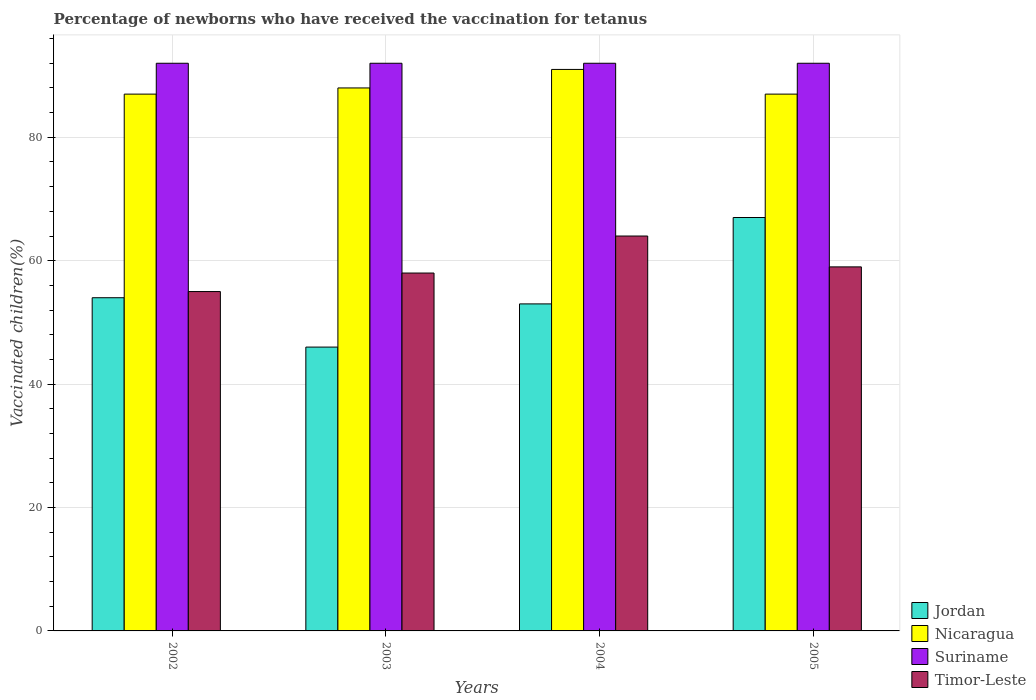How many groups of bars are there?
Ensure brevity in your answer.  4. Are the number of bars on each tick of the X-axis equal?
Ensure brevity in your answer.  Yes. How many bars are there on the 1st tick from the right?
Give a very brief answer. 4. What is the label of the 2nd group of bars from the left?
Give a very brief answer. 2003. Across all years, what is the maximum percentage of vaccinated children in Suriname?
Your answer should be very brief. 92. What is the total percentage of vaccinated children in Timor-Leste in the graph?
Your answer should be compact. 236. What is the difference between the percentage of vaccinated children in Suriname in 2003 and that in 2004?
Your response must be concise. 0. What is the difference between the percentage of vaccinated children in Jordan in 2003 and the percentage of vaccinated children in Timor-Leste in 2002?
Your answer should be compact. -9. What is the average percentage of vaccinated children in Timor-Leste per year?
Your answer should be compact. 59. What is the ratio of the percentage of vaccinated children in Nicaragua in 2002 to that in 2005?
Your answer should be very brief. 1. What is the difference between the highest and the second highest percentage of vaccinated children in Jordan?
Your answer should be very brief. 13. In how many years, is the percentage of vaccinated children in Suriname greater than the average percentage of vaccinated children in Suriname taken over all years?
Your answer should be compact. 0. Is the sum of the percentage of vaccinated children in Suriname in 2004 and 2005 greater than the maximum percentage of vaccinated children in Nicaragua across all years?
Offer a very short reply. Yes. What does the 3rd bar from the left in 2002 represents?
Offer a very short reply. Suriname. What does the 2nd bar from the right in 2005 represents?
Your answer should be very brief. Suriname. Are all the bars in the graph horizontal?
Ensure brevity in your answer.  No. How many years are there in the graph?
Provide a short and direct response. 4. What is the difference between two consecutive major ticks on the Y-axis?
Provide a short and direct response. 20. Are the values on the major ticks of Y-axis written in scientific E-notation?
Offer a very short reply. No. Does the graph contain any zero values?
Give a very brief answer. No. Does the graph contain grids?
Your response must be concise. Yes. Where does the legend appear in the graph?
Keep it short and to the point. Bottom right. How many legend labels are there?
Give a very brief answer. 4. How are the legend labels stacked?
Provide a short and direct response. Vertical. What is the title of the graph?
Offer a terse response. Percentage of newborns who have received the vaccination for tetanus. What is the label or title of the Y-axis?
Make the answer very short. Vaccinated children(%). What is the Vaccinated children(%) in Jordan in 2002?
Provide a short and direct response. 54. What is the Vaccinated children(%) in Nicaragua in 2002?
Offer a terse response. 87. What is the Vaccinated children(%) in Suriname in 2002?
Ensure brevity in your answer.  92. What is the Vaccinated children(%) of Timor-Leste in 2002?
Give a very brief answer. 55. What is the Vaccinated children(%) of Jordan in 2003?
Your answer should be very brief. 46. What is the Vaccinated children(%) of Suriname in 2003?
Offer a very short reply. 92. What is the Vaccinated children(%) of Timor-Leste in 2003?
Your response must be concise. 58. What is the Vaccinated children(%) of Jordan in 2004?
Your answer should be very brief. 53. What is the Vaccinated children(%) in Nicaragua in 2004?
Offer a very short reply. 91. What is the Vaccinated children(%) of Suriname in 2004?
Offer a very short reply. 92. What is the Vaccinated children(%) of Timor-Leste in 2004?
Ensure brevity in your answer.  64. What is the Vaccinated children(%) of Jordan in 2005?
Provide a short and direct response. 67. What is the Vaccinated children(%) in Suriname in 2005?
Offer a very short reply. 92. What is the Vaccinated children(%) of Timor-Leste in 2005?
Keep it short and to the point. 59. Across all years, what is the maximum Vaccinated children(%) in Jordan?
Give a very brief answer. 67. Across all years, what is the maximum Vaccinated children(%) in Nicaragua?
Offer a very short reply. 91. Across all years, what is the maximum Vaccinated children(%) of Suriname?
Provide a succinct answer. 92. Across all years, what is the minimum Vaccinated children(%) in Jordan?
Provide a short and direct response. 46. Across all years, what is the minimum Vaccinated children(%) in Nicaragua?
Keep it short and to the point. 87. Across all years, what is the minimum Vaccinated children(%) of Suriname?
Provide a short and direct response. 92. What is the total Vaccinated children(%) in Jordan in the graph?
Provide a short and direct response. 220. What is the total Vaccinated children(%) in Nicaragua in the graph?
Ensure brevity in your answer.  353. What is the total Vaccinated children(%) of Suriname in the graph?
Provide a short and direct response. 368. What is the total Vaccinated children(%) in Timor-Leste in the graph?
Your response must be concise. 236. What is the difference between the Vaccinated children(%) of Jordan in 2002 and that in 2003?
Your answer should be compact. 8. What is the difference between the Vaccinated children(%) of Nicaragua in 2002 and that in 2003?
Give a very brief answer. -1. What is the difference between the Vaccinated children(%) of Suriname in 2002 and that in 2003?
Ensure brevity in your answer.  0. What is the difference between the Vaccinated children(%) in Timor-Leste in 2002 and that in 2003?
Your response must be concise. -3. What is the difference between the Vaccinated children(%) in Jordan in 2002 and that in 2005?
Your response must be concise. -13. What is the difference between the Vaccinated children(%) of Nicaragua in 2002 and that in 2005?
Your answer should be compact. 0. What is the difference between the Vaccinated children(%) in Suriname in 2003 and that in 2004?
Offer a terse response. 0. What is the difference between the Vaccinated children(%) in Nicaragua in 2003 and that in 2005?
Provide a succinct answer. 1. What is the difference between the Vaccinated children(%) of Jordan in 2004 and that in 2005?
Ensure brevity in your answer.  -14. What is the difference between the Vaccinated children(%) of Nicaragua in 2004 and that in 2005?
Make the answer very short. 4. What is the difference between the Vaccinated children(%) in Suriname in 2004 and that in 2005?
Provide a succinct answer. 0. What is the difference between the Vaccinated children(%) in Timor-Leste in 2004 and that in 2005?
Offer a very short reply. 5. What is the difference between the Vaccinated children(%) in Jordan in 2002 and the Vaccinated children(%) in Nicaragua in 2003?
Provide a succinct answer. -34. What is the difference between the Vaccinated children(%) in Jordan in 2002 and the Vaccinated children(%) in Suriname in 2003?
Make the answer very short. -38. What is the difference between the Vaccinated children(%) in Suriname in 2002 and the Vaccinated children(%) in Timor-Leste in 2003?
Provide a succinct answer. 34. What is the difference between the Vaccinated children(%) of Jordan in 2002 and the Vaccinated children(%) of Nicaragua in 2004?
Provide a succinct answer. -37. What is the difference between the Vaccinated children(%) of Jordan in 2002 and the Vaccinated children(%) of Suriname in 2004?
Provide a succinct answer. -38. What is the difference between the Vaccinated children(%) in Nicaragua in 2002 and the Vaccinated children(%) in Timor-Leste in 2004?
Your answer should be compact. 23. What is the difference between the Vaccinated children(%) in Jordan in 2002 and the Vaccinated children(%) in Nicaragua in 2005?
Offer a terse response. -33. What is the difference between the Vaccinated children(%) of Jordan in 2002 and the Vaccinated children(%) of Suriname in 2005?
Offer a very short reply. -38. What is the difference between the Vaccinated children(%) in Nicaragua in 2002 and the Vaccinated children(%) in Suriname in 2005?
Provide a short and direct response. -5. What is the difference between the Vaccinated children(%) of Nicaragua in 2002 and the Vaccinated children(%) of Timor-Leste in 2005?
Your response must be concise. 28. What is the difference between the Vaccinated children(%) of Jordan in 2003 and the Vaccinated children(%) of Nicaragua in 2004?
Keep it short and to the point. -45. What is the difference between the Vaccinated children(%) of Jordan in 2003 and the Vaccinated children(%) of Suriname in 2004?
Keep it short and to the point. -46. What is the difference between the Vaccinated children(%) in Jordan in 2003 and the Vaccinated children(%) in Timor-Leste in 2004?
Make the answer very short. -18. What is the difference between the Vaccinated children(%) of Nicaragua in 2003 and the Vaccinated children(%) of Timor-Leste in 2004?
Keep it short and to the point. 24. What is the difference between the Vaccinated children(%) in Suriname in 2003 and the Vaccinated children(%) in Timor-Leste in 2004?
Your response must be concise. 28. What is the difference between the Vaccinated children(%) of Jordan in 2003 and the Vaccinated children(%) of Nicaragua in 2005?
Your answer should be very brief. -41. What is the difference between the Vaccinated children(%) in Jordan in 2003 and the Vaccinated children(%) in Suriname in 2005?
Provide a succinct answer. -46. What is the difference between the Vaccinated children(%) of Nicaragua in 2003 and the Vaccinated children(%) of Suriname in 2005?
Give a very brief answer. -4. What is the difference between the Vaccinated children(%) of Nicaragua in 2003 and the Vaccinated children(%) of Timor-Leste in 2005?
Offer a terse response. 29. What is the difference between the Vaccinated children(%) in Suriname in 2003 and the Vaccinated children(%) in Timor-Leste in 2005?
Your answer should be very brief. 33. What is the difference between the Vaccinated children(%) of Jordan in 2004 and the Vaccinated children(%) of Nicaragua in 2005?
Offer a terse response. -34. What is the difference between the Vaccinated children(%) of Jordan in 2004 and the Vaccinated children(%) of Suriname in 2005?
Your answer should be very brief. -39. What is the difference between the Vaccinated children(%) of Jordan in 2004 and the Vaccinated children(%) of Timor-Leste in 2005?
Your response must be concise. -6. What is the difference between the Vaccinated children(%) in Nicaragua in 2004 and the Vaccinated children(%) in Timor-Leste in 2005?
Provide a short and direct response. 32. What is the average Vaccinated children(%) of Jordan per year?
Keep it short and to the point. 55. What is the average Vaccinated children(%) in Nicaragua per year?
Offer a very short reply. 88.25. What is the average Vaccinated children(%) of Suriname per year?
Make the answer very short. 92. In the year 2002, what is the difference between the Vaccinated children(%) of Jordan and Vaccinated children(%) of Nicaragua?
Ensure brevity in your answer.  -33. In the year 2002, what is the difference between the Vaccinated children(%) of Jordan and Vaccinated children(%) of Suriname?
Your response must be concise. -38. In the year 2002, what is the difference between the Vaccinated children(%) in Jordan and Vaccinated children(%) in Timor-Leste?
Keep it short and to the point. -1. In the year 2002, what is the difference between the Vaccinated children(%) of Suriname and Vaccinated children(%) of Timor-Leste?
Give a very brief answer. 37. In the year 2003, what is the difference between the Vaccinated children(%) of Jordan and Vaccinated children(%) of Nicaragua?
Your answer should be very brief. -42. In the year 2003, what is the difference between the Vaccinated children(%) of Jordan and Vaccinated children(%) of Suriname?
Ensure brevity in your answer.  -46. In the year 2003, what is the difference between the Vaccinated children(%) of Nicaragua and Vaccinated children(%) of Timor-Leste?
Offer a very short reply. 30. In the year 2003, what is the difference between the Vaccinated children(%) in Suriname and Vaccinated children(%) in Timor-Leste?
Make the answer very short. 34. In the year 2004, what is the difference between the Vaccinated children(%) in Jordan and Vaccinated children(%) in Nicaragua?
Provide a short and direct response. -38. In the year 2004, what is the difference between the Vaccinated children(%) of Jordan and Vaccinated children(%) of Suriname?
Offer a very short reply. -39. In the year 2004, what is the difference between the Vaccinated children(%) in Jordan and Vaccinated children(%) in Timor-Leste?
Keep it short and to the point. -11. In the year 2004, what is the difference between the Vaccinated children(%) in Suriname and Vaccinated children(%) in Timor-Leste?
Ensure brevity in your answer.  28. In the year 2005, what is the difference between the Vaccinated children(%) in Jordan and Vaccinated children(%) in Nicaragua?
Provide a short and direct response. -20. In the year 2005, what is the difference between the Vaccinated children(%) of Jordan and Vaccinated children(%) of Suriname?
Your answer should be compact. -25. In the year 2005, what is the difference between the Vaccinated children(%) of Jordan and Vaccinated children(%) of Timor-Leste?
Your answer should be compact. 8. In the year 2005, what is the difference between the Vaccinated children(%) in Nicaragua and Vaccinated children(%) in Timor-Leste?
Offer a very short reply. 28. What is the ratio of the Vaccinated children(%) in Jordan in 2002 to that in 2003?
Provide a succinct answer. 1.17. What is the ratio of the Vaccinated children(%) of Suriname in 2002 to that in 2003?
Keep it short and to the point. 1. What is the ratio of the Vaccinated children(%) in Timor-Leste in 2002 to that in 2003?
Offer a terse response. 0.95. What is the ratio of the Vaccinated children(%) in Jordan in 2002 to that in 2004?
Make the answer very short. 1.02. What is the ratio of the Vaccinated children(%) in Nicaragua in 2002 to that in 2004?
Your answer should be compact. 0.96. What is the ratio of the Vaccinated children(%) in Timor-Leste in 2002 to that in 2004?
Ensure brevity in your answer.  0.86. What is the ratio of the Vaccinated children(%) of Jordan in 2002 to that in 2005?
Make the answer very short. 0.81. What is the ratio of the Vaccinated children(%) in Nicaragua in 2002 to that in 2005?
Offer a terse response. 1. What is the ratio of the Vaccinated children(%) of Timor-Leste in 2002 to that in 2005?
Provide a short and direct response. 0.93. What is the ratio of the Vaccinated children(%) of Jordan in 2003 to that in 2004?
Your answer should be very brief. 0.87. What is the ratio of the Vaccinated children(%) of Suriname in 2003 to that in 2004?
Give a very brief answer. 1. What is the ratio of the Vaccinated children(%) in Timor-Leste in 2003 to that in 2004?
Make the answer very short. 0.91. What is the ratio of the Vaccinated children(%) in Jordan in 2003 to that in 2005?
Keep it short and to the point. 0.69. What is the ratio of the Vaccinated children(%) in Nicaragua in 2003 to that in 2005?
Give a very brief answer. 1.01. What is the ratio of the Vaccinated children(%) in Timor-Leste in 2003 to that in 2005?
Your answer should be compact. 0.98. What is the ratio of the Vaccinated children(%) of Jordan in 2004 to that in 2005?
Your answer should be very brief. 0.79. What is the ratio of the Vaccinated children(%) in Nicaragua in 2004 to that in 2005?
Ensure brevity in your answer.  1.05. What is the ratio of the Vaccinated children(%) of Suriname in 2004 to that in 2005?
Make the answer very short. 1. What is the ratio of the Vaccinated children(%) of Timor-Leste in 2004 to that in 2005?
Make the answer very short. 1.08. What is the difference between the highest and the second highest Vaccinated children(%) of Jordan?
Your answer should be very brief. 13. What is the difference between the highest and the second highest Vaccinated children(%) in Timor-Leste?
Offer a terse response. 5. What is the difference between the highest and the lowest Vaccinated children(%) of Nicaragua?
Make the answer very short. 4. 